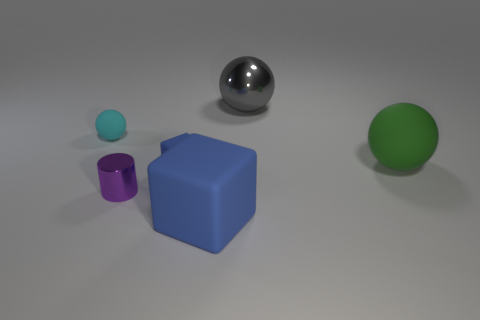What is the size of the matte cube on the left side of the blue block in front of the small blue thing?
Your response must be concise. Small. What number of things are large gray rubber balls or tiny rubber objects?
Make the answer very short. 2. Is the shape of the small cyan object the same as the large green rubber object?
Your answer should be very brief. Yes. Is there another big thing made of the same material as the purple object?
Your answer should be compact. Yes. There is a small rubber block that is on the right side of the tiny purple shiny object; is there a tiny blue object that is behind it?
Ensure brevity in your answer.  No. Is the size of the matte ball that is to the left of the green object the same as the gray shiny thing?
Offer a terse response. No. The green matte sphere is what size?
Give a very brief answer. Large. Is there a shiny cylinder of the same color as the metal ball?
Provide a short and direct response. No. How many tiny things are things or purple cylinders?
Make the answer very short. 3. What size is the rubber thing that is in front of the green ball and behind the tiny purple object?
Provide a succinct answer. Small. 